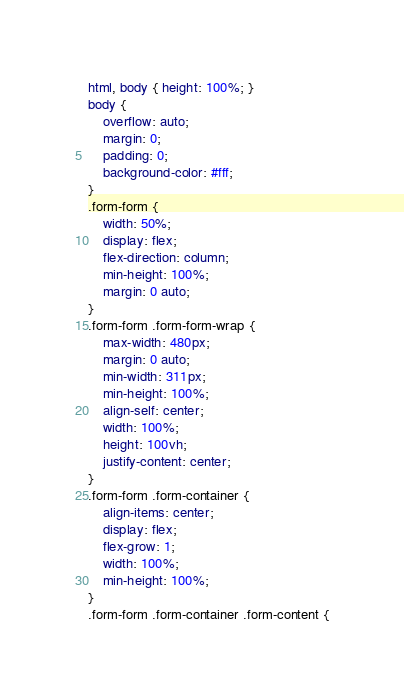Convert code to text. <code><loc_0><loc_0><loc_500><loc_500><_CSS_>html, body { height: 100%; }
body {
    overflow: auto;
    margin: 0;
    padding: 0;
    background-color: #fff;
}
.form-form {
    width: 50%;
    display: flex;
    flex-direction: column;
    min-height: 100%;
    margin: 0 auto;
}
.form-form .form-form-wrap {
    max-width: 480px;
    margin: 0 auto;
    min-width: 311px;
    min-height: 100%;
    align-self: center;
    width: 100%;
    height: 100vh;
    justify-content: center; 
}
.form-form .form-container {
    align-items: center;
    display: flex;
    flex-grow: 1;
    width: 100%;
    min-height: 100%;
}
.form-form .form-container .form-content {</code> 